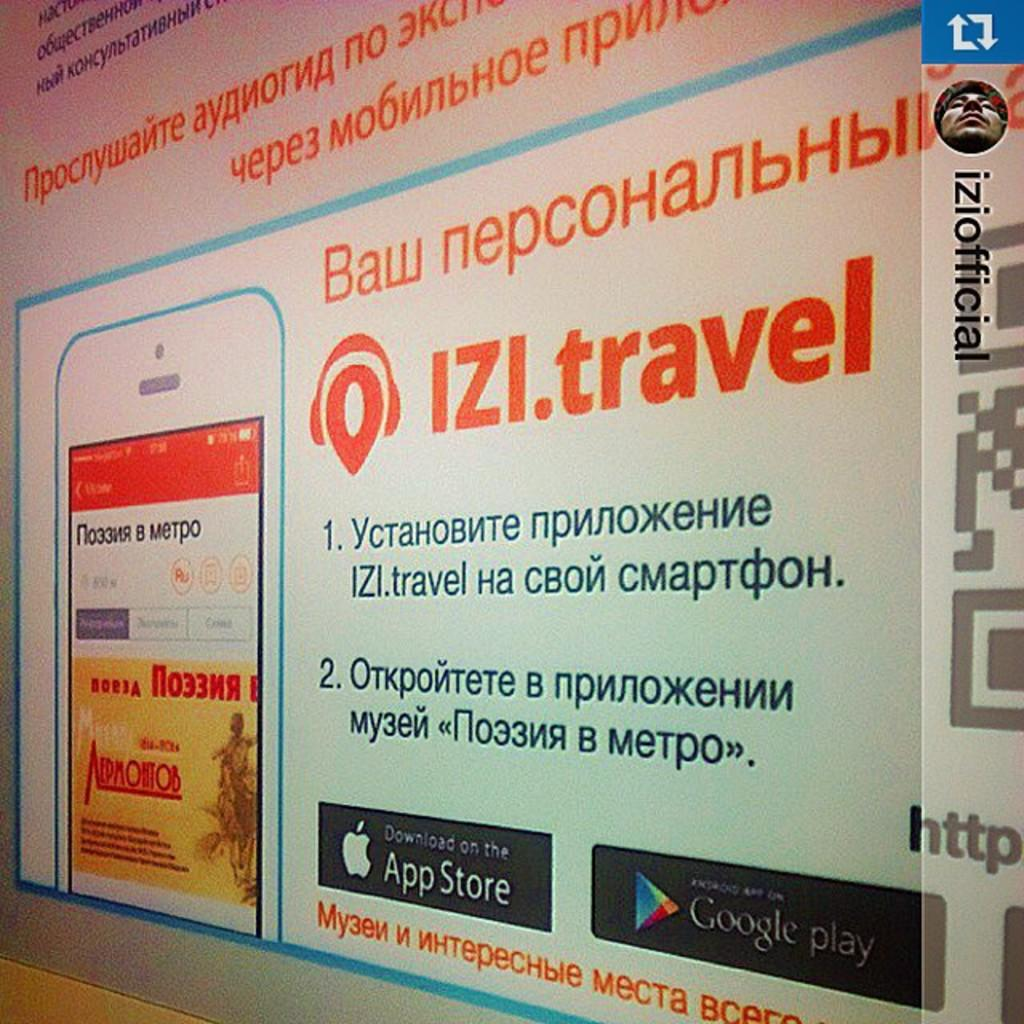<image>
Render a clear and concise summary of the photo. A large advertisment on a wall for IZI.travel. 